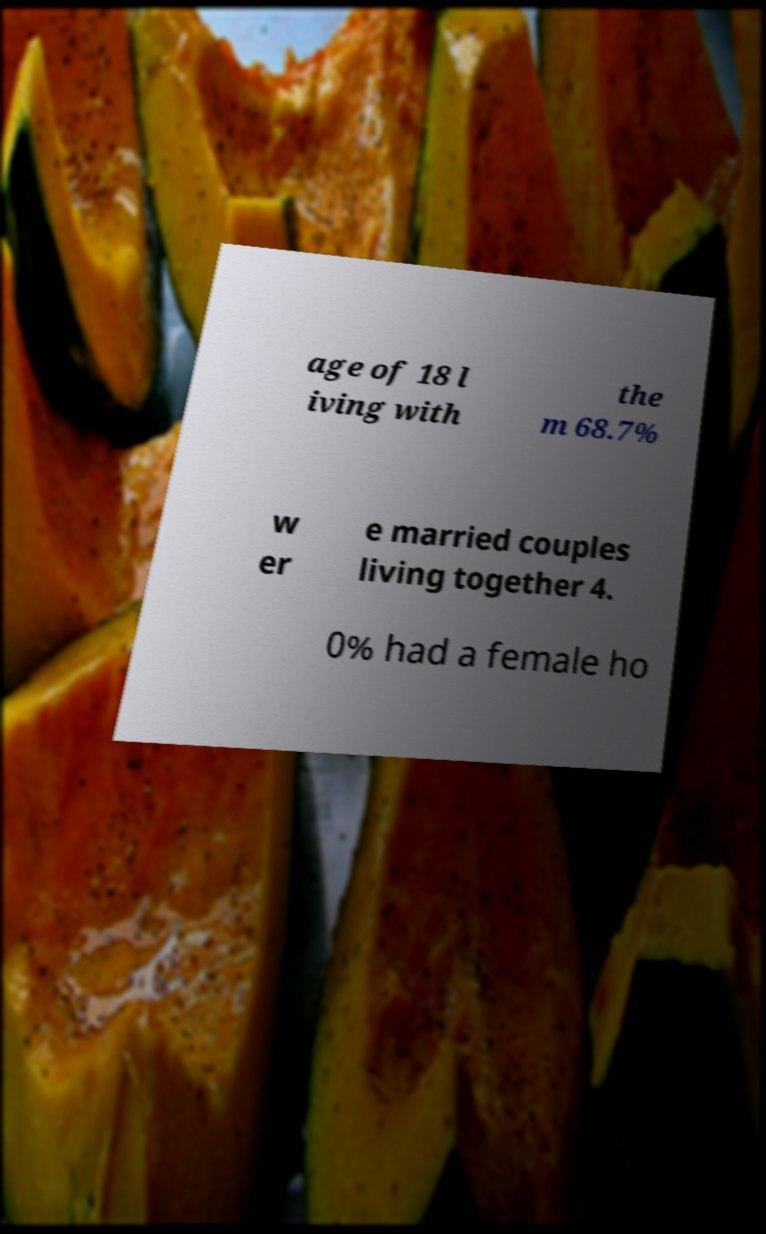Can you read and provide the text displayed in the image?This photo seems to have some interesting text. Can you extract and type it out for me? age of 18 l iving with the m 68.7% w er e married couples living together 4. 0% had a female ho 